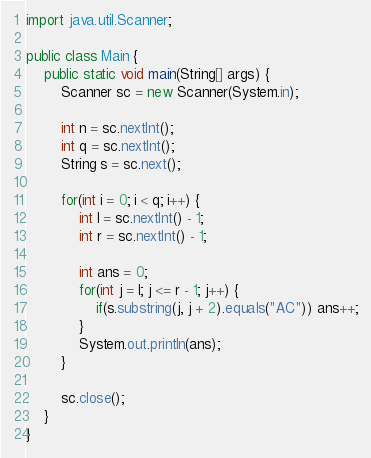<code> <loc_0><loc_0><loc_500><loc_500><_Java_>import java.util.Scanner;

public class Main {
    public static void main(String[] args) {
        Scanner sc = new Scanner(System.in);

        int n = sc.nextInt();
        int q = sc.nextInt();
        String s = sc.next();

        for(int i = 0; i < q; i++) {
            int l = sc.nextInt() - 1;
            int r = sc.nextInt() - 1;

            int ans = 0;
            for(int j = l; j <= r - 1; j++) {
                if(s.substring(j, j + 2).equals("AC")) ans++;
            }
            System.out.println(ans);
        }

        sc.close();
    }
}</code> 